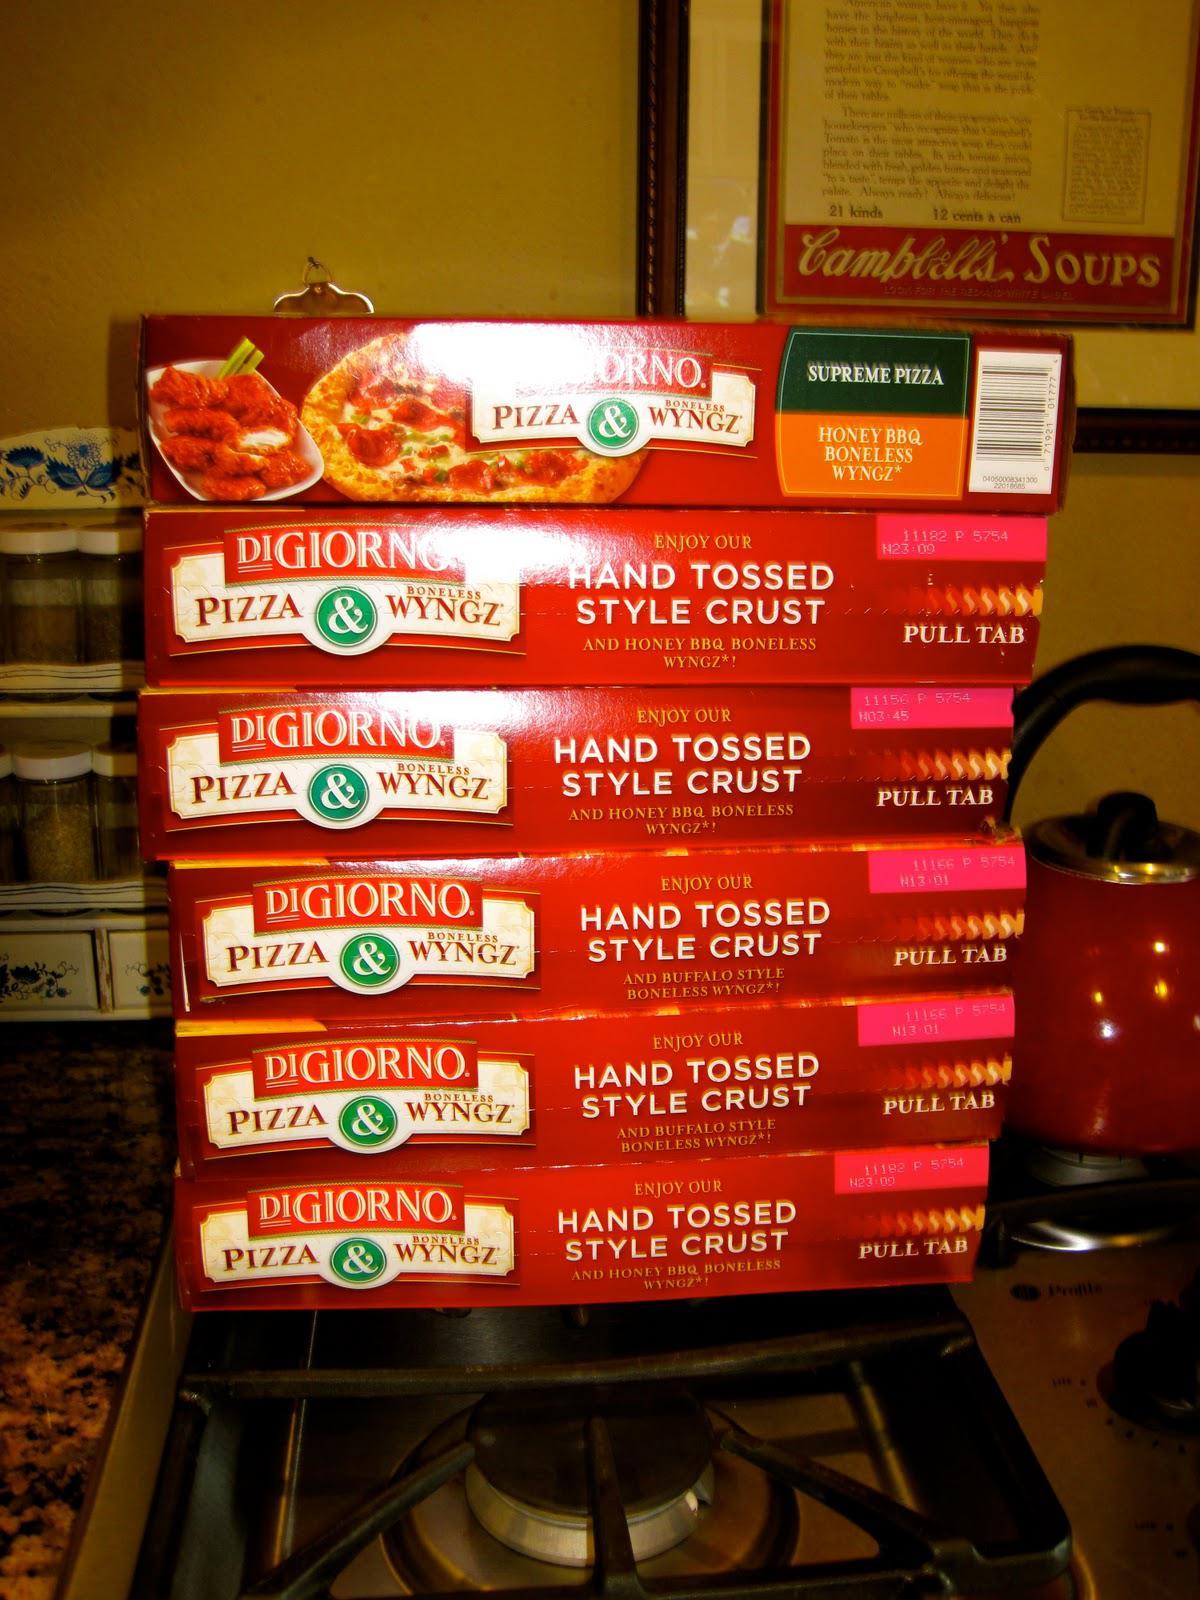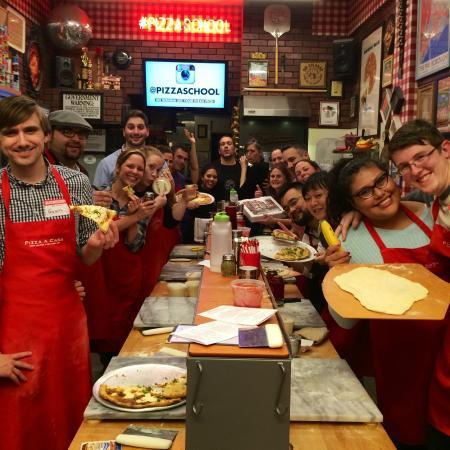The first image is the image on the left, the second image is the image on the right. For the images shown, is this caption "Both pizza packs contain Wyngz." true? Answer yes or no. No. The first image is the image on the left, the second image is the image on the right. Considering the images on both sides, is "An image shows a pizza box that depicts pizza on the left and coated chicken pieces on the right." valid? Answer yes or no. No. 